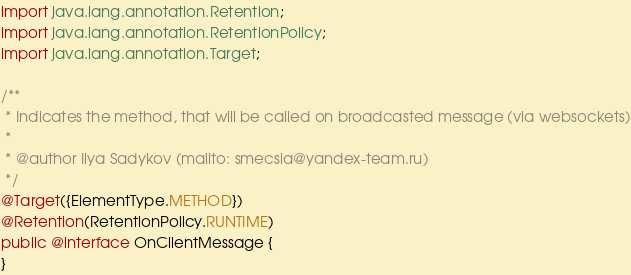<code> <loc_0><loc_0><loc_500><loc_500><_Java_>import java.lang.annotation.Retention;
import java.lang.annotation.RetentionPolicy;
import java.lang.annotation.Target;

/**
 * Indicates the method, that will be called on broadcasted message (via websockets)
 *
 * @author Ilya Sadykov (mailto: smecsia@yandex-team.ru)
 */
@Target({ElementType.METHOD})
@Retention(RetentionPolicy.RUNTIME)
public @interface OnClientMessage {
}
</code> 